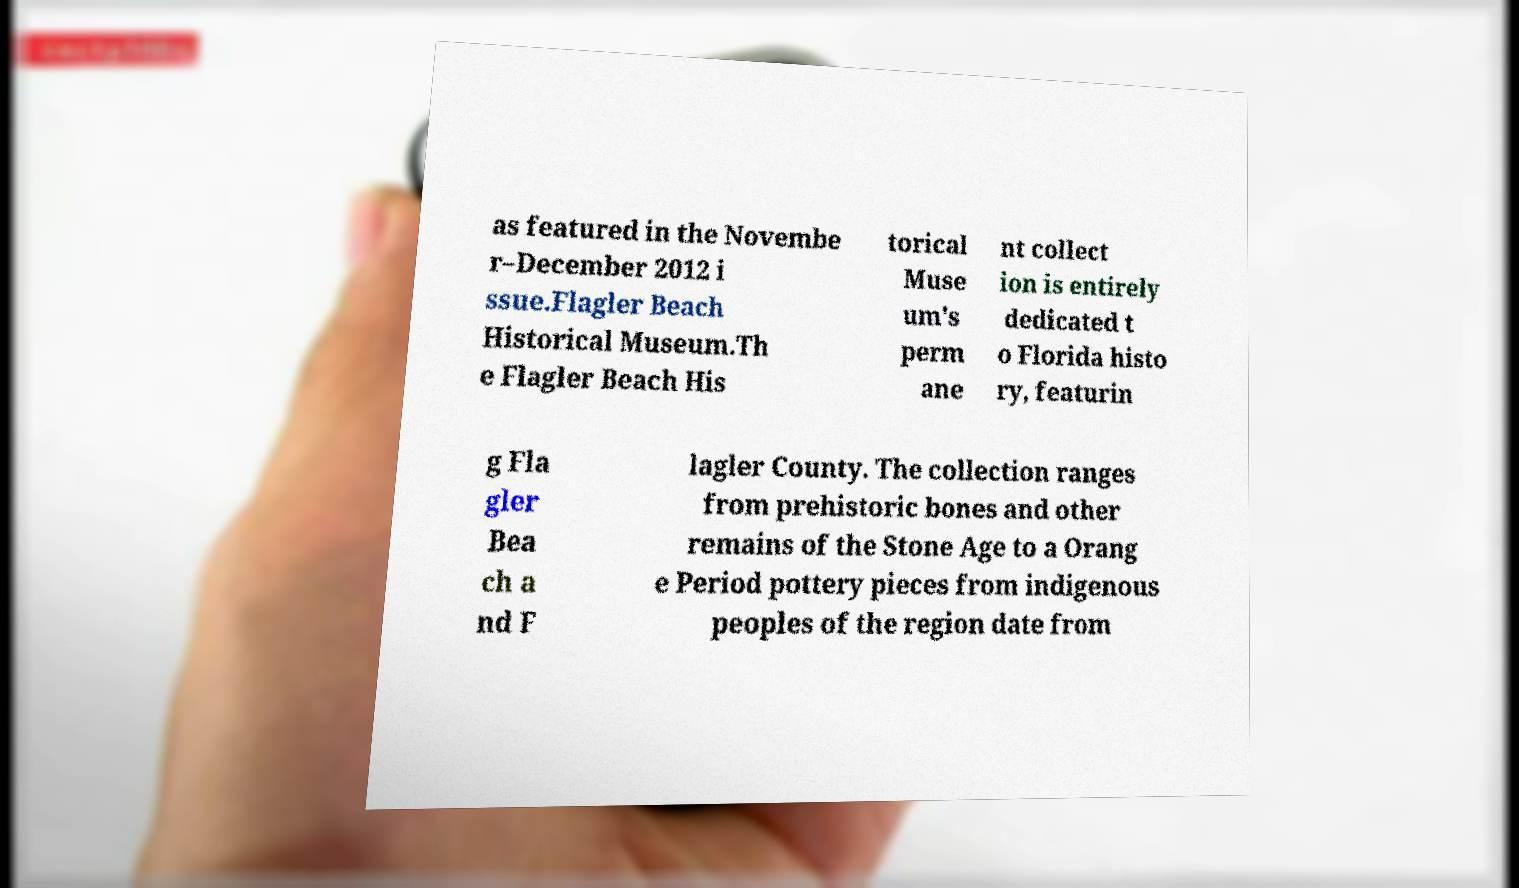Could you extract and type out the text from this image? as featured in the Novembe r–December 2012 i ssue.Flagler Beach Historical Museum.Th e Flagler Beach His torical Muse um's perm ane nt collect ion is entirely dedicated t o Florida histo ry, featurin g Fla gler Bea ch a nd F lagler County. The collection ranges from prehistoric bones and other remains of the Stone Age to a Orang e Period pottery pieces from indigenous peoples of the region date from 